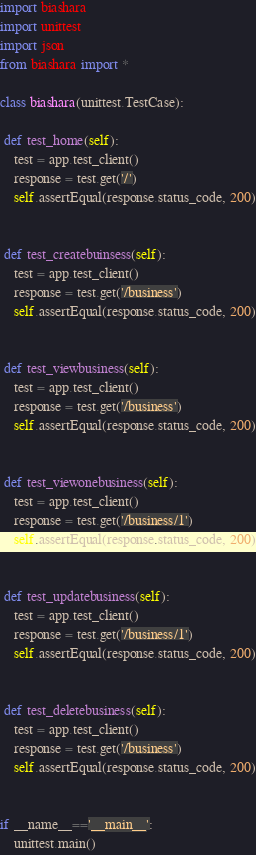Convert code to text. <code><loc_0><loc_0><loc_500><loc_500><_Python_>import biashara
import unittest
import json
from biashara import *

class biashara(unittest.TestCase):

 def test_home(self):
    test = app.test_client()
    response = test.get('/')
    self.assertEqual(response.status_code, 200)


 def test_createbuinsess(self):
    test = app.test_client()
    response = test.get('/business')
    self.assertEqual(response.status_code, 200)


 def test_viewbusiness(self):
    test = app.test_client()
    response = test.get('/business')
    self.assertEqual(response.status_code, 200)


 def test_viewonebusiness(self):
    test = app.test_client()
    response = test.get('/business/1')
    self.assertEqual(response.status_code, 200)


 def test_updatebusiness(self):
    test = app.test_client()
    response = test.get('/business/1')
    self.assertEqual(response.status_code, 200)


 def test_deletebusiness(self):
    test = app.test_client()
    response = test.get('/business')
    self.assertEqual(response.status_code, 200)


if __name__=='__main__':
    unittest.main()
</code> 